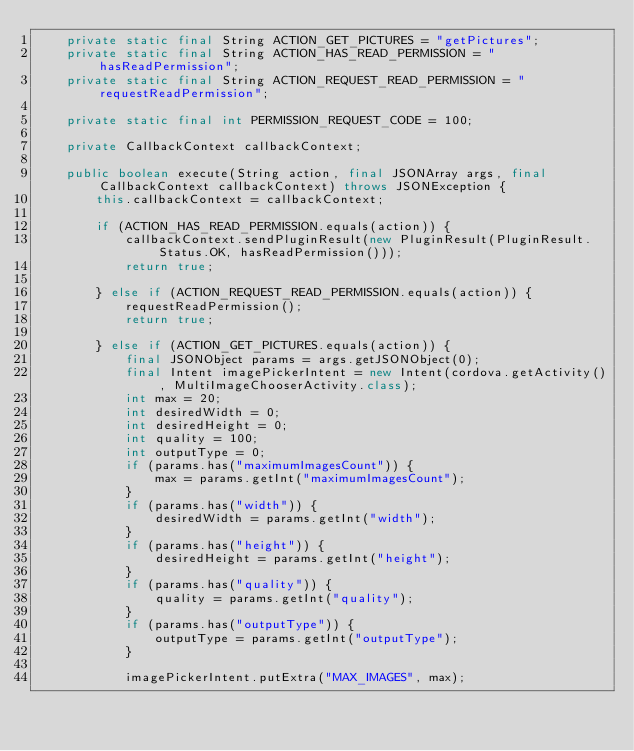<code> <loc_0><loc_0><loc_500><loc_500><_Java_>    private static final String ACTION_GET_PICTURES = "getPictures";
    private static final String ACTION_HAS_READ_PERMISSION = "hasReadPermission";
    private static final String ACTION_REQUEST_READ_PERMISSION = "requestReadPermission";

    private static final int PERMISSION_REQUEST_CODE = 100;

    private CallbackContext callbackContext;

    public boolean execute(String action, final JSONArray args, final CallbackContext callbackContext) throws JSONException {
        this.callbackContext = callbackContext;

        if (ACTION_HAS_READ_PERMISSION.equals(action)) {
            callbackContext.sendPluginResult(new PluginResult(PluginResult.Status.OK, hasReadPermission()));
            return true;

        } else if (ACTION_REQUEST_READ_PERMISSION.equals(action)) {
            requestReadPermission();
            return true;

        } else if (ACTION_GET_PICTURES.equals(action)) {
            final JSONObject params = args.getJSONObject(0);
            final Intent imagePickerIntent = new Intent(cordova.getActivity(), MultiImageChooserActivity.class);
            int max = 20;
            int desiredWidth = 0;
            int desiredHeight = 0;
            int quality = 100;
            int outputType = 0;
            if (params.has("maximumImagesCount")) {
                max = params.getInt("maximumImagesCount");
            }
            if (params.has("width")) {
                desiredWidth = params.getInt("width");
            }
            if (params.has("height")) {
                desiredHeight = params.getInt("height");
            }
            if (params.has("quality")) {
                quality = params.getInt("quality");
            }
            if (params.has("outputType")) {
                outputType = params.getInt("outputType");
            }

            imagePickerIntent.putExtra("MAX_IMAGES", max);</code> 